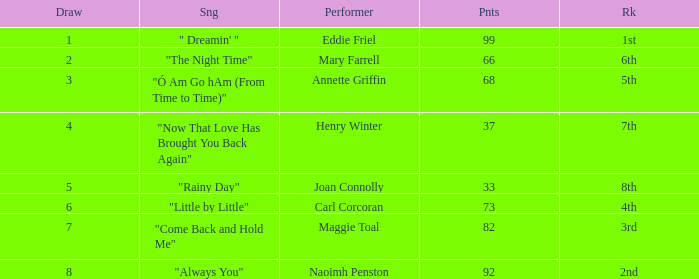What is the lowest points when the ranking is 1st? 99.0. 